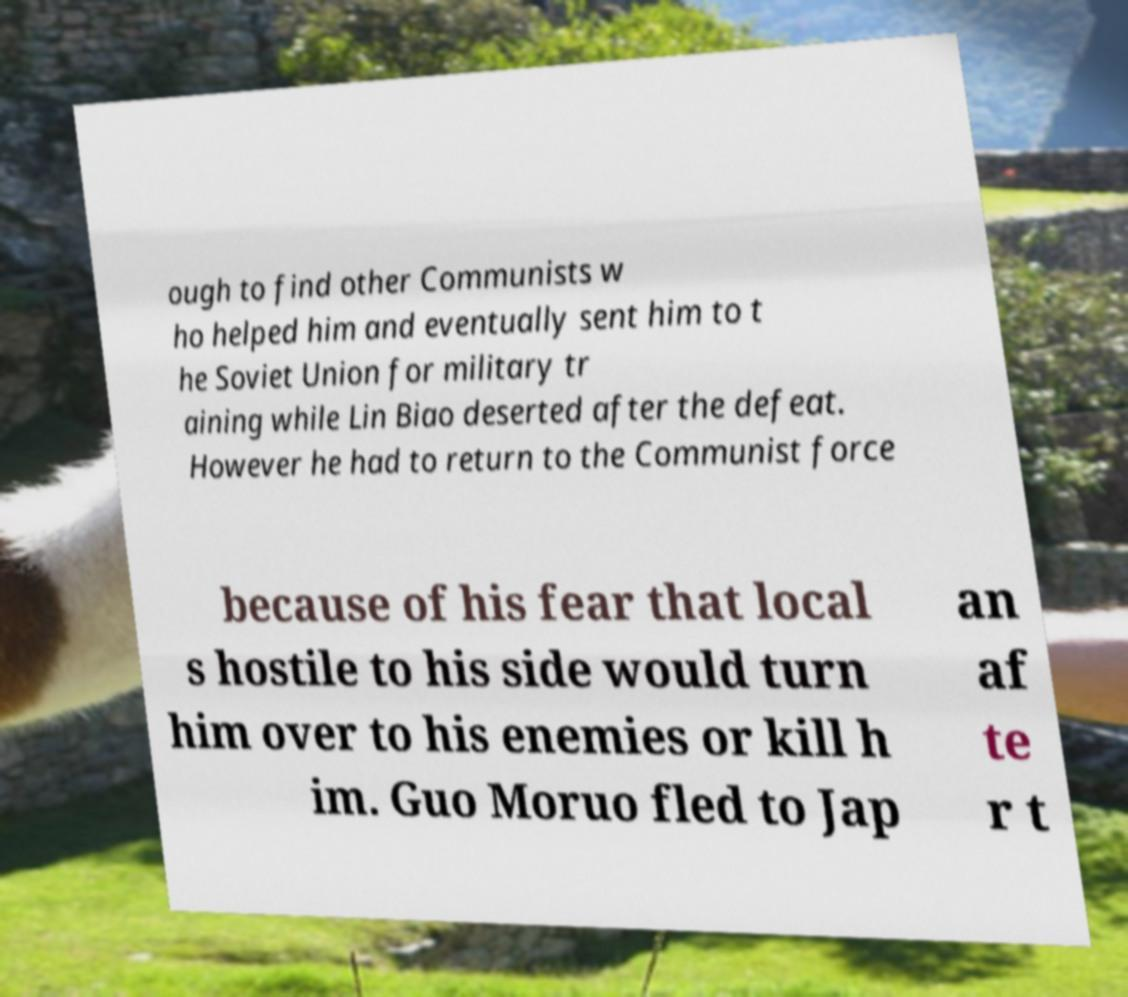What messages or text are displayed in this image? I need them in a readable, typed format. ough to find other Communists w ho helped him and eventually sent him to t he Soviet Union for military tr aining while Lin Biao deserted after the defeat. However he had to return to the Communist force because of his fear that local s hostile to his side would turn him over to his enemies or kill h im. Guo Moruo fled to Jap an af te r t 